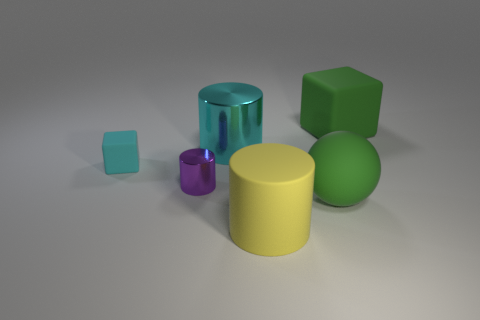Is there anything else that is the same color as the big sphere?
Offer a terse response. Yes. What size is the rubber cube that is to the left of the green matte block?
Make the answer very short. Small. Do the big matte block and the big sphere that is on the right side of the small metallic object have the same color?
Your answer should be compact. Yes. What number of other objects are there of the same material as the purple cylinder?
Provide a succinct answer. 1. Is the number of blocks greater than the number of red metallic cubes?
Your response must be concise. Yes. Does the rubber thing that is to the left of the rubber cylinder have the same color as the large shiny thing?
Give a very brief answer. Yes. What color is the tiny rubber cube?
Make the answer very short. Cyan. There is a cube that is on the right side of the big yellow object; is there a green thing that is in front of it?
Offer a very short reply. Yes. The green rubber object that is in front of the big cylinder that is behind the big yellow rubber cylinder is what shape?
Keep it short and to the point. Sphere. Are there fewer matte blocks than red objects?
Provide a short and direct response. No. 